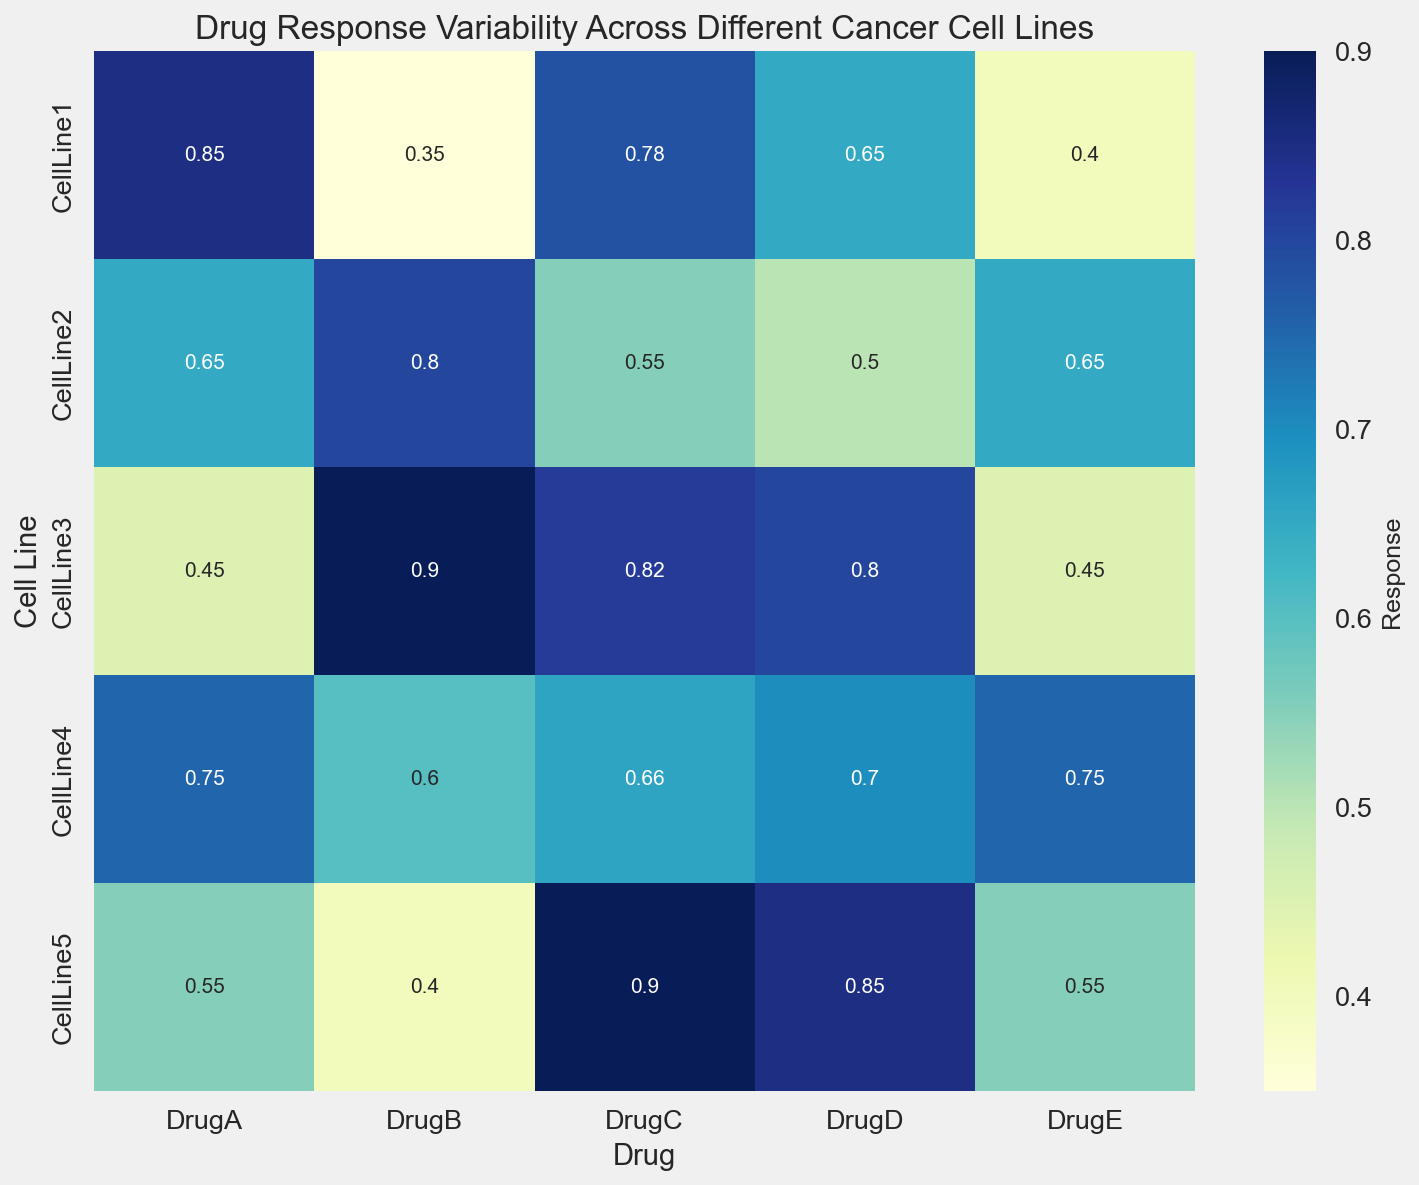How does the response to DrugA compare to DrugE across all Cell Lines? To find how the responses compare between DrugA and DrugE, we'll look at the corresponding response values for each Cell Line. DrugA: [0.85, 0.65, 0.45, 0.75, 0.55], DrugE: [0.40, 0.65, 0.45, 0.75, 0.55]. Now, we compare corresponding elements: CellLine1: DrugA > DrugE, CellLine2: DrugA = DrugE, CellLine3: DrugA = DrugE, CellLine4: DrugA = DrugE, CellLine5: DrugA = DrugE. Therefore, for CellLine1, DrugA has a higher response than DrugE, while for the other cell lines, the responses are equal.
Answer: DrugA is higher for CellLine1, equal for all others Which drug has the highest response for CellLine3? To determine which drug has the highest response for CellLine3, we look at the response values for CellLine3: DrugA: 0.45, DrugB: 0.90, DrugC: 0.82, DrugD: 0.80, DrugE: 0.45. The highest value among these is 0.90 for DrugB.
Answer: DrugB What is the average response across all drugs for CellLine5? First, we find the responses for CellLine5: DrugA: 0.55, DrugB: 0.40, DrugC: 0.90, DrugD: 0.85, DrugE: 0.55. Next, we calculate the average: (0.55 + 0.40 + 0.90 + 0.85 +0.55) / 5 = 3.25 / 5 = 0.65.
Answer: 0.65 Which cell line has the lowest average drug response? Calculate the average response for each cell line by summing the responses and dividing by the number of drugs: CellLine1: (0.85 + 0.35 + 0.78 + 0.65 + 0.40) / 5 = 0.606, CellLine2: (0.65 + 0.80 + 0.55 + 0.50 + 0.65) / 5 = 0.63, CellLine3: (0.45 + 0.90 + 0.82 + 0.80 + 0.45) / 5 = 0.684, CellLine4: (0.75 + 0.60 + 0.66 + 0.70 + 0.75) / 5 = 0.692, CellLine5: (0.55 + 0.40 + 0.90 + 0.85 + 0.55) / 5 = 0.65. The lowest average response is for CellLine1: 0.606.
Answer: CellLine1 Which drug demonstrates the most variability in response across the cell lines? To determine the variability, we need to look at the range (difference between max and min response) for each drug: DrugA: max(0.85) - min(0.45) = 0.40, DrugB: max(0.90) - min(0.35) = 0.55, DrugC: max(0.90) - min(0.55) = 0.35, DrugD: max(0.85) - min(0.50) = 0.35, DrugE: max(0.75) - min(0.40) = 0.35. DrugB has the highest range, indicating the most variability.
Answer: DrugB What is the median response for DrugD across all cell lines? The responses for DrugD are [0.65, 0.50, 0.80, 0.70, 0.85]. To find the median, we sort these values: [0.50, 0.65, 0.70, 0.80, 0.85]. The median value is the middle one: 0.70.
Answer: 0.70 Which pair of Drugs has the most similar pattern of responses across the cell lines? To identify similar patterns, we compare the responses visually or compute correlations. For simplicity, visually comparing, we find: DrugA: [0.85, 0.65, 0.45, 0.75, 0.55], DrugE: [0.40, 0.65, 0.45, 0.75, 0.55]—the sequences are very similar indicating DrugA and DrugE have the most similar pattern.
Answer: DrugA and DrugE 